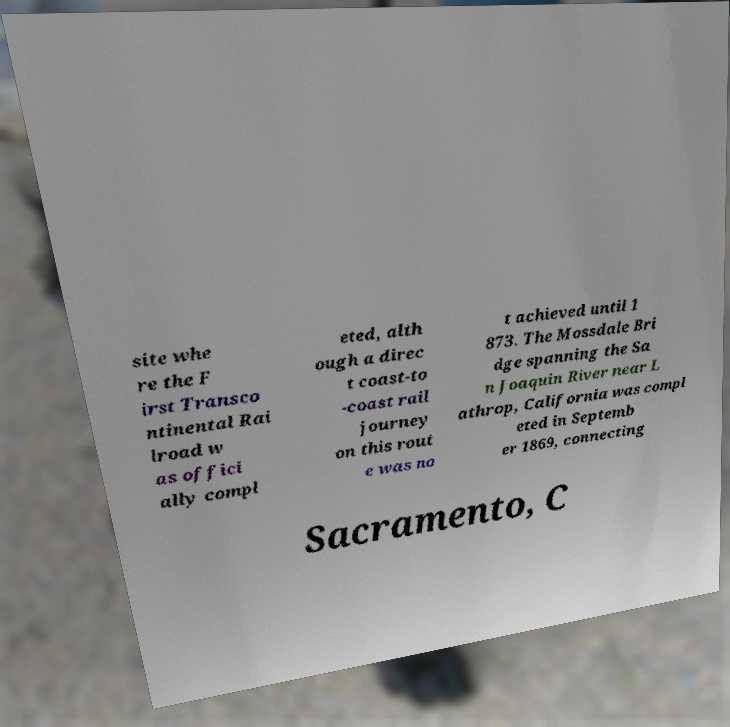Could you extract and type out the text from this image? site whe re the F irst Transco ntinental Rai lroad w as offici ally compl eted, alth ough a direc t coast-to -coast rail journey on this rout e was no t achieved until 1 873. The Mossdale Bri dge spanning the Sa n Joaquin River near L athrop, California was compl eted in Septemb er 1869, connecting Sacramento, C 